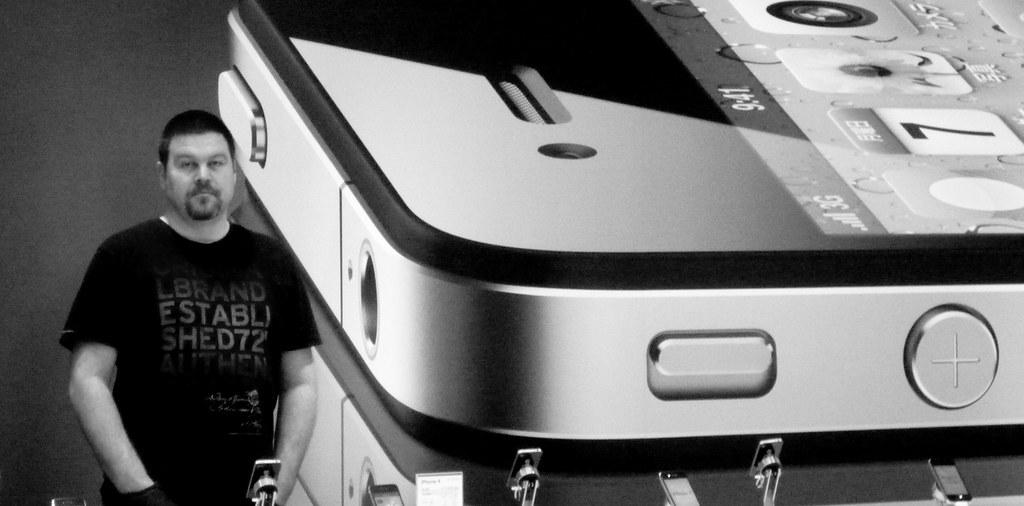What is the main subject of the image? The main subject of the image is a man standing. What can be observed about the man's attire? The man is wearing clothes. What type of object is depicted in the image? There is a picture of a mobile phone in the image. What else can be seen in the image besides the man and the mobile phone? There are gadgets visible in the image. What type of sticks are being used by the nation in the image? There is no mention of a nation or sticks in the image; it features a man standing and gadgets. 